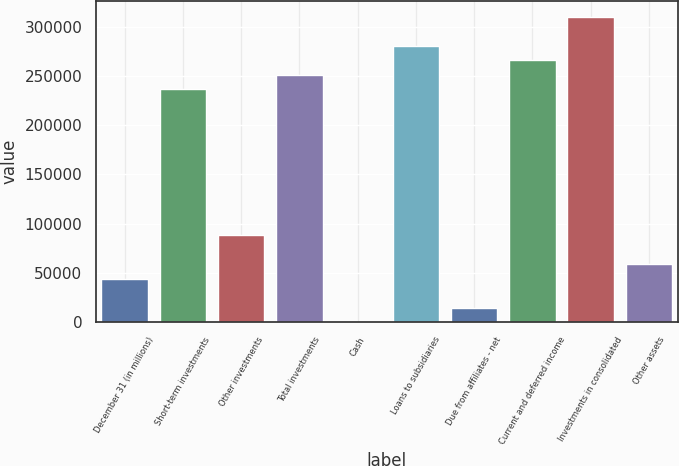Convert chart. <chart><loc_0><loc_0><loc_500><loc_500><bar_chart><fcel>December 31 (in millions)<fcel>Short-term investments<fcel>Other investments<fcel>Total investments<fcel>Cash<fcel>Loans to subsidiaries<fcel>Due from affiliates - net<fcel>Current and deferred income<fcel>Investments in consolidated<fcel>Other assets<nl><fcel>44380.2<fcel>236343<fcel>88679.4<fcel>251110<fcel>81<fcel>280643<fcel>14847.4<fcel>265876<fcel>310175<fcel>59146.6<nl></chart> 